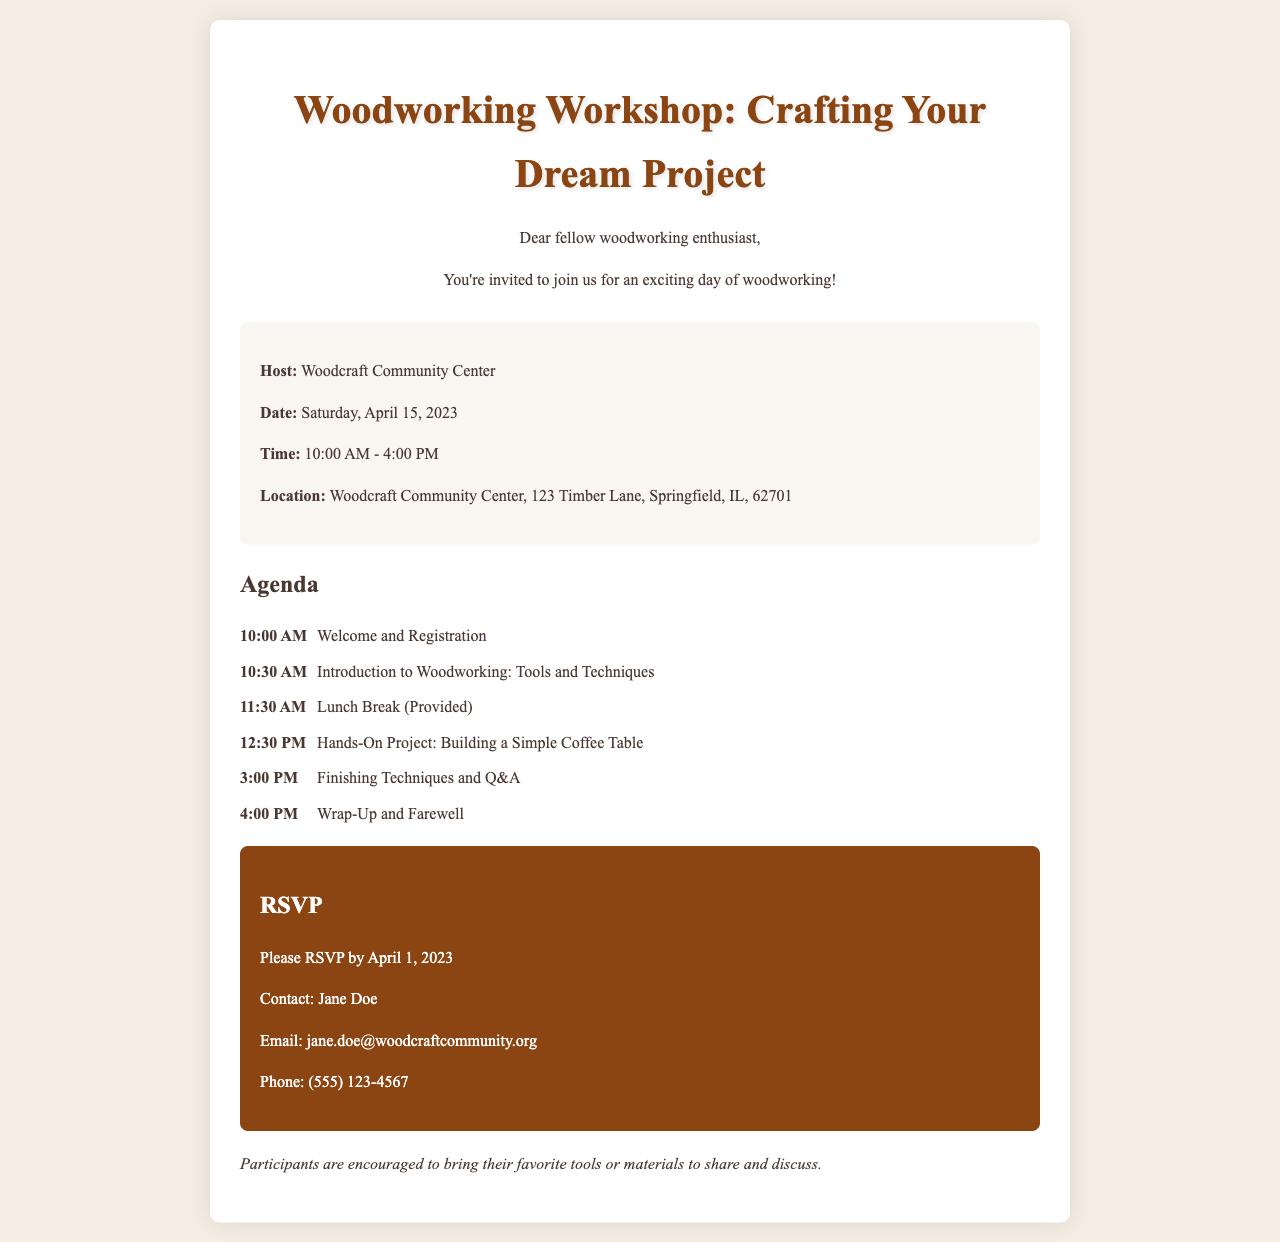What is the date of the workshop? The date of the workshop is specifically mentioned in the document.
Answer: Saturday, April 15, 2023 Where is the woodworking workshop being held? The location of the workshop is provided in the details section of the document.
Answer: Woodcraft Community Center, 123 Timber Lane, Springfield, IL, 62701 What is the main project participants will work on? The agenda includes a specific hands-on project participants will undertake.
Answer: Building a Simple Coffee Table What time does the workshop start? The starting time is explicitly stated in the agenda section of the document.
Answer: 10:00 AM What is the RSVP deadline? The document specifies a particular date by which participants must RSVP.
Answer: April 1, 2023 Who should be contacted for the RSVP? The contact person for RSVPs is mentioned in the document.
Answer: Jane Doe What will be provided during the lunch break? The lunch break section specifies something related to food during the workshop.
Answer: Lunch (Provided) What will be discussed in the introduction session? The agenda outlines what will be covered in the introduction to woodworking segment.
Answer: Tools and Techniques 